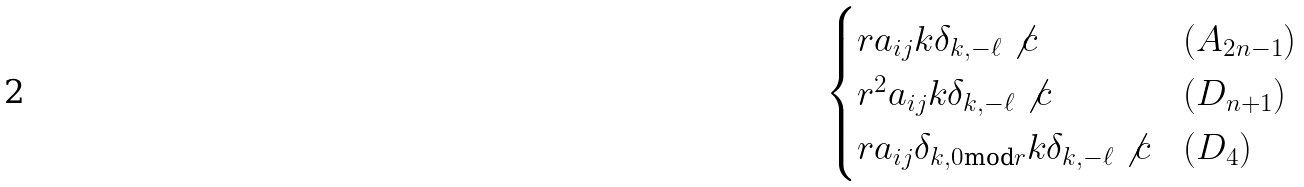Convert formula to latex. <formula><loc_0><loc_0><loc_500><loc_500>\begin{cases} r a _ { i j } k \delta _ { k , - \ell } \not { c } & ( A _ { 2 n - 1 } ) \\ r ^ { 2 } a _ { i j } k \delta _ { k , - \ell } \not { c } & ( D _ { n + 1 } ) \\ r a _ { i j } \delta _ { k , 0 \text {mod} r } k \delta _ { k , - \ell } \not { c } & ( D _ { 4 } ) \end{cases}</formula> 